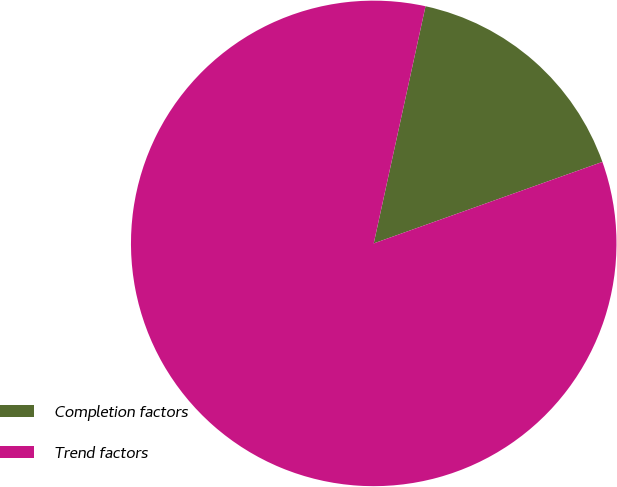Convert chart. <chart><loc_0><loc_0><loc_500><loc_500><pie_chart><fcel>Completion factors<fcel>Trend factors<nl><fcel>16.13%<fcel>83.87%<nl></chart> 